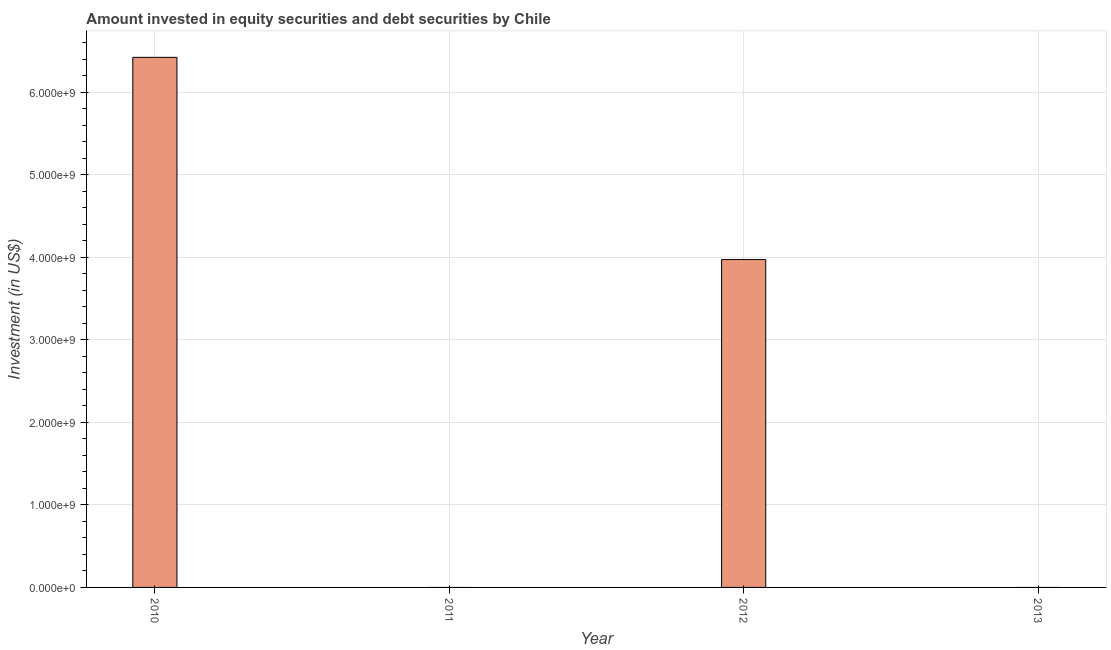Does the graph contain grids?
Keep it short and to the point. Yes. What is the title of the graph?
Give a very brief answer. Amount invested in equity securities and debt securities by Chile. What is the label or title of the Y-axis?
Offer a terse response. Investment (in US$). Across all years, what is the maximum portfolio investment?
Keep it short and to the point. 6.42e+09. What is the sum of the portfolio investment?
Offer a terse response. 1.04e+1. What is the average portfolio investment per year?
Ensure brevity in your answer.  2.60e+09. What is the median portfolio investment?
Offer a terse response. 1.99e+09. In how many years, is the portfolio investment greater than 2800000000 US$?
Your answer should be compact. 2. What is the ratio of the portfolio investment in 2010 to that in 2012?
Your response must be concise. 1.62. Is the portfolio investment in 2010 less than that in 2012?
Offer a very short reply. No. Is the difference between the portfolio investment in 2010 and 2012 greater than the difference between any two years?
Provide a succinct answer. No. Is the sum of the portfolio investment in 2010 and 2012 greater than the maximum portfolio investment across all years?
Make the answer very short. Yes. What is the difference between the highest and the lowest portfolio investment?
Ensure brevity in your answer.  6.42e+09. In how many years, is the portfolio investment greater than the average portfolio investment taken over all years?
Offer a terse response. 2. How many bars are there?
Provide a short and direct response. 2. Are all the bars in the graph horizontal?
Offer a terse response. No. How many years are there in the graph?
Offer a very short reply. 4. What is the Investment (in US$) of 2010?
Ensure brevity in your answer.  6.42e+09. What is the Investment (in US$) in 2011?
Make the answer very short. 0. What is the Investment (in US$) of 2012?
Give a very brief answer. 3.97e+09. What is the Investment (in US$) of 2013?
Your answer should be very brief. 0. What is the difference between the Investment (in US$) in 2010 and 2012?
Make the answer very short. 2.45e+09. What is the ratio of the Investment (in US$) in 2010 to that in 2012?
Ensure brevity in your answer.  1.62. 